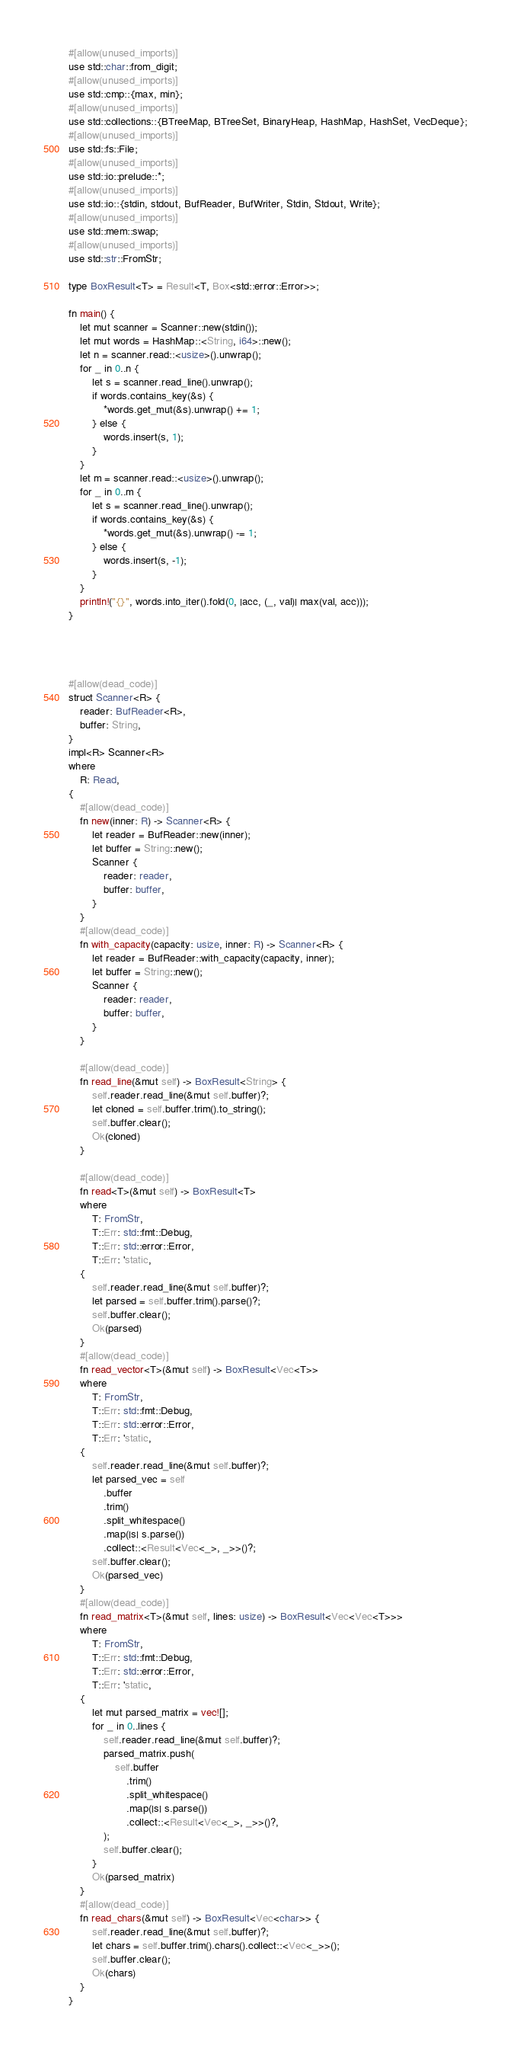<code> <loc_0><loc_0><loc_500><loc_500><_Rust_>#[allow(unused_imports)]
use std::char::from_digit;
#[allow(unused_imports)]
use std::cmp::{max, min};
#[allow(unused_imports)]
use std::collections::{BTreeMap, BTreeSet, BinaryHeap, HashMap, HashSet, VecDeque};
#[allow(unused_imports)]
use std::fs::File;
#[allow(unused_imports)]
use std::io::prelude::*;
#[allow(unused_imports)]
use std::io::{stdin, stdout, BufReader, BufWriter, Stdin, Stdout, Write};
#[allow(unused_imports)]
use std::mem::swap;
#[allow(unused_imports)]
use std::str::FromStr;

type BoxResult<T> = Result<T, Box<std::error::Error>>;

fn main() {
    let mut scanner = Scanner::new(stdin());
    let mut words = HashMap::<String, i64>::new();
    let n = scanner.read::<usize>().unwrap();
    for _ in 0..n {
        let s = scanner.read_line().unwrap();
        if words.contains_key(&s) {
            *words.get_mut(&s).unwrap() += 1;
        } else {
            words.insert(s, 1);
        }
    }
    let m = scanner.read::<usize>().unwrap();
    for _ in 0..m {
        let s = scanner.read_line().unwrap();
        if words.contains_key(&s) {
            *words.get_mut(&s).unwrap() -= 1;
        } else {
            words.insert(s, -1);
        }
    }
    println!("{}", words.into_iter().fold(0, |acc, (_, val)| max(val, acc)));
}




#[allow(dead_code)]
struct Scanner<R> {
    reader: BufReader<R>,
    buffer: String,
}
impl<R> Scanner<R>
where
    R: Read,
{
    #[allow(dead_code)]
    fn new(inner: R) -> Scanner<R> {
        let reader = BufReader::new(inner);
        let buffer = String::new();
        Scanner {
            reader: reader,
            buffer: buffer,
        }
    }
    #[allow(dead_code)]
    fn with_capacity(capacity: usize, inner: R) -> Scanner<R> {
        let reader = BufReader::with_capacity(capacity, inner);
        let buffer = String::new();
        Scanner {
            reader: reader,
            buffer: buffer,
        }
    }

    #[allow(dead_code)]
    fn read_line(&mut self) -> BoxResult<String> {
        self.reader.read_line(&mut self.buffer)?;
        let cloned = self.buffer.trim().to_string();
        self.buffer.clear();
        Ok(cloned)
    }

    #[allow(dead_code)]
    fn read<T>(&mut self) -> BoxResult<T>
    where
        T: FromStr,
        T::Err: std::fmt::Debug,
        T::Err: std::error::Error,
        T::Err: 'static,
    {
        self.reader.read_line(&mut self.buffer)?;
        let parsed = self.buffer.trim().parse()?;
        self.buffer.clear();
        Ok(parsed)
    }
    #[allow(dead_code)]
    fn read_vector<T>(&mut self) -> BoxResult<Vec<T>>
    where
        T: FromStr,
        T::Err: std::fmt::Debug,
        T::Err: std::error::Error,
        T::Err: 'static,
    {
        self.reader.read_line(&mut self.buffer)?;
        let parsed_vec = self
            .buffer
            .trim()
            .split_whitespace()
            .map(|s| s.parse())
            .collect::<Result<Vec<_>, _>>()?;
        self.buffer.clear();
        Ok(parsed_vec)
    }
    #[allow(dead_code)]
    fn read_matrix<T>(&mut self, lines: usize) -> BoxResult<Vec<Vec<T>>>
    where
        T: FromStr,
        T::Err: std::fmt::Debug,
        T::Err: std::error::Error,
        T::Err: 'static,
    {
        let mut parsed_matrix = vec![];
        for _ in 0..lines {
            self.reader.read_line(&mut self.buffer)?;
            parsed_matrix.push(
                self.buffer
                    .trim()
                    .split_whitespace()
                    .map(|s| s.parse())
                    .collect::<Result<Vec<_>, _>>()?,
            );
            self.buffer.clear();
        }
        Ok(parsed_matrix)
    }
    #[allow(dead_code)]
    fn read_chars(&mut self) -> BoxResult<Vec<char>> {
        self.reader.read_line(&mut self.buffer)?;
        let chars = self.buffer.trim().chars().collect::<Vec<_>>();
        self.buffer.clear();
        Ok(chars)
    }
}
</code> 